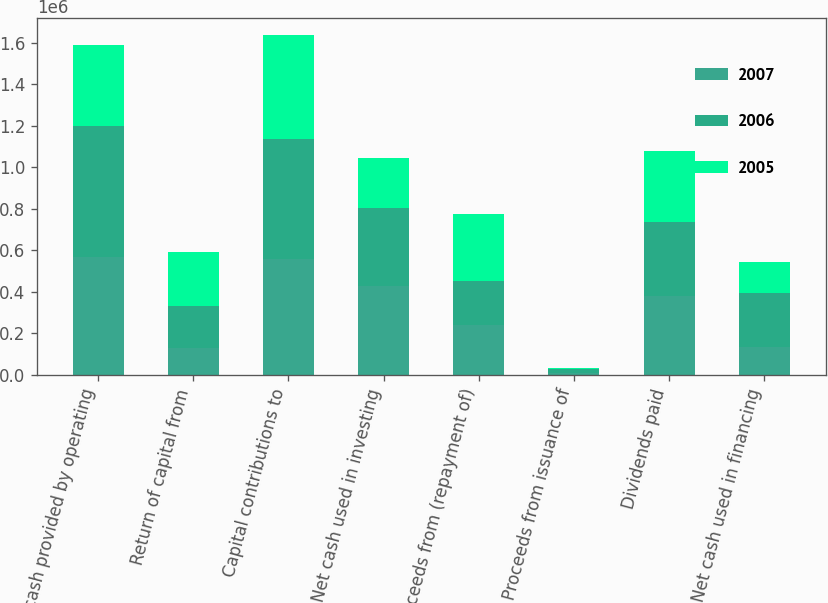<chart> <loc_0><loc_0><loc_500><loc_500><stacked_bar_chart><ecel><fcel>Net cash provided by operating<fcel>Return of capital from<fcel>Capital contributions to<fcel>Net cash used in investing<fcel>Proceeds from (repayment of)<fcel>Proceeds from issuance of<fcel>Dividends paid<fcel>Net cash used in financing<nl><fcel>2007<fcel>566688<fcel>129551<fcel>559266<fcel>429715<fcel>238877<fcel>10539<fcel>378892<fcel>134335<nl><fcel>2006<fcel>634128<fcel>201185<fcel>576600<fcel>375415<fcel>211716<fcel>16275<fcel>358746<fcel>259357<nl><fcel>2005<fcel>391776<fcel>262378<fcel>504402<fcel>242024<fcel>325516<fcel>9085<fcel>343092<fcel>148667<nl></chart> 